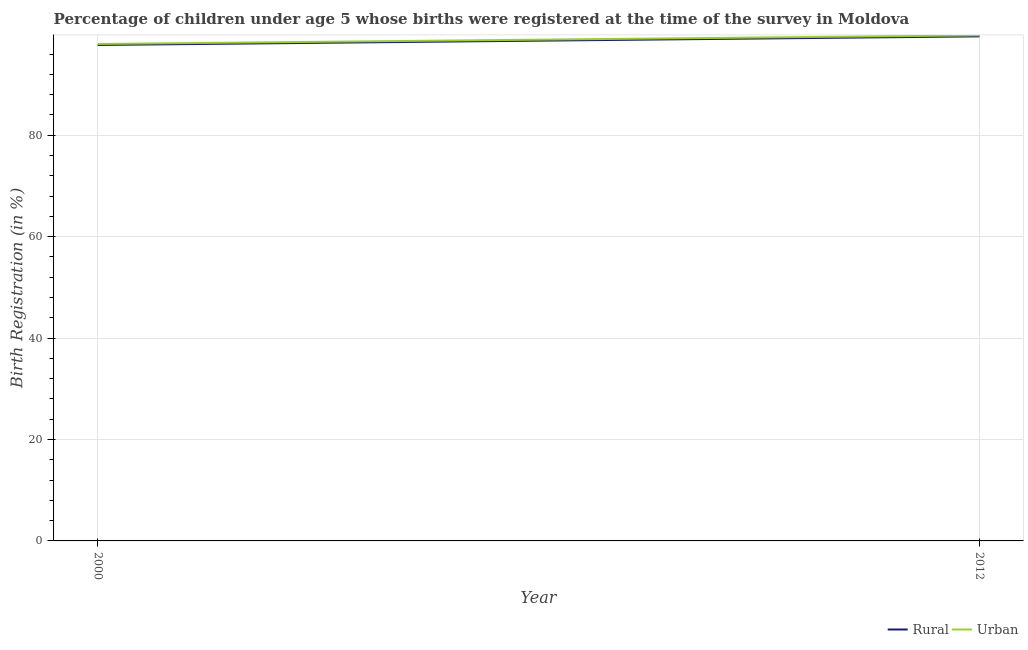How many different coloured lines are there?
Provide a succinct answer. 2. Does the line corresponding to urban birth registration intersect with the line corresponding to rural birth registration?
Provide a short and direct response. No. Is the number of lines equal to the number of legend labels?
Your answer should be compact. Yes. What is the rural birth registration in 2000?
Your answer should be compact. 97.8. Across all years, what is the maximum rural birth registration?
Provide a short and direct response. 99.5. Across all years, what is the minimum rural birth registration?
Your response must be concise. 97.8. In which year was the urban birth registration minimum?
Give a very brief answer. 2000. What is the total rural birth registration in the graph?
Your response must be concise. 197.3. What is the difference between the urban birth registration in 2000 and that in 2012?
Offer a terse response. -1.7. What is the average rural birth registration per year?
Your answer should be very brief. 98.65. In the year 2012, what is the difference between the urban birth registration and rural birth registration?
Provide a short and direct response. 0.2. What is the ratio of the rural birth registration in 2000 to that in 2012?
Give a very brief answer. 0.98. In how many years, is the rural birth registration greater than the average rural birth registration taken over all years?
Your answer should be very brief. 1. Does the rural birth registration monotonically increase over the years?
Make the answer very short. Yes. Is the urban birth registration strictly greater than the rural birth registration over the years?
Your response must be concise. Yes. How many years are there in the graph?
Provide a succinct answer. 2. Does the graph contain grids?
Keep it short and to the point. Yes. Where does the legend appear in the graph?
Keep it short and to the point. Bottom right. How many legend labels are there?
Make the answer very short. 2. What is the title of the graph?
Your response must be concise. Percentage of children under age 5 whose births were registered at the time of the survey in Moldova. Does "Researchers" appear as one of the legend labels in the graph?
Your response must be concise. No. What is the label or title of the Y-axis?
Give a very brief answer. Birth Registration (in %). What is the Birth Registration (in %) of Rural in 2000?
Your answer should be compact. 97.8. What is the Birth Registration (in %) in Urban in 2000?
Provide a succinct answer. 98. What is the Birth Registration (in %) of Rural in 2012?
Keep it short and to the point. 99.5. What is the Birth Registration (in %) in Urban in 2012?
Make the answer very short. 99.7. Across all years, what is the maximum Birth Registration (in %) in Rural?
Your answer should be very brief. 99.5. Across all years, what is the maximum Birth Registration (in %) in Urban?
Keep it short and to the point. 99.7. Across all years, what is the minimum Birth Registration (in %) in Rural?
Make the answer very short. 97.8. What is the total Birth Registration (in %) of Rural in the graph?
Your answer should be very brief. 197.3. What is the total Birth Registration (in %) of Urban in the graph?
Your answer should be compact. 197.7. What is the difference between the Birth Registration (in %) in Rural in 2000 and that in 2012?
Provide a short and direct response. -1.7. What is the difference between the Birth Registration (in %) in Urban in 2000 and that in 2012?
Your answer should be compact. -1.7. What is the difference between the Birth Registration (in %) of Rural in 2000 and the Birth Registration (in %) of Urban in 2012?
Provide a short and direct response. -1.9. What is the average Birth Registration (in %) of Rural per year?
Offer a very short reply. 98.65. What is the average Birth Registration (in %) in Urban per year?
Provide a succinct answer. 98.85. What is the ratio of the Birth Registration (in %) of Rural in 2000 to that in 2012?
Make the answer very short. 0.98. What is the ratio of the Birth Registration (in %) in Urban in 2000 to that in 2012?
Keep it short and to the point. 0.98. What is the difference between the highest and the second highest Birth Registration (in %) of Rural?
Keep it short and to the point. 1.7. What is the difference between the highest and the lowest Birth Registration (in %) in Rural?
Ensure brevity in your answer.  1.7. 